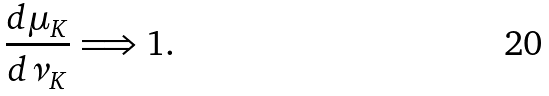Convert formula to latex. <formula><loc_0><loc_0><loc_500><loc_500>\frac { d \mu _ { K } } { d \nu _ { K } } \Longrightarrow 1 .</formula> 